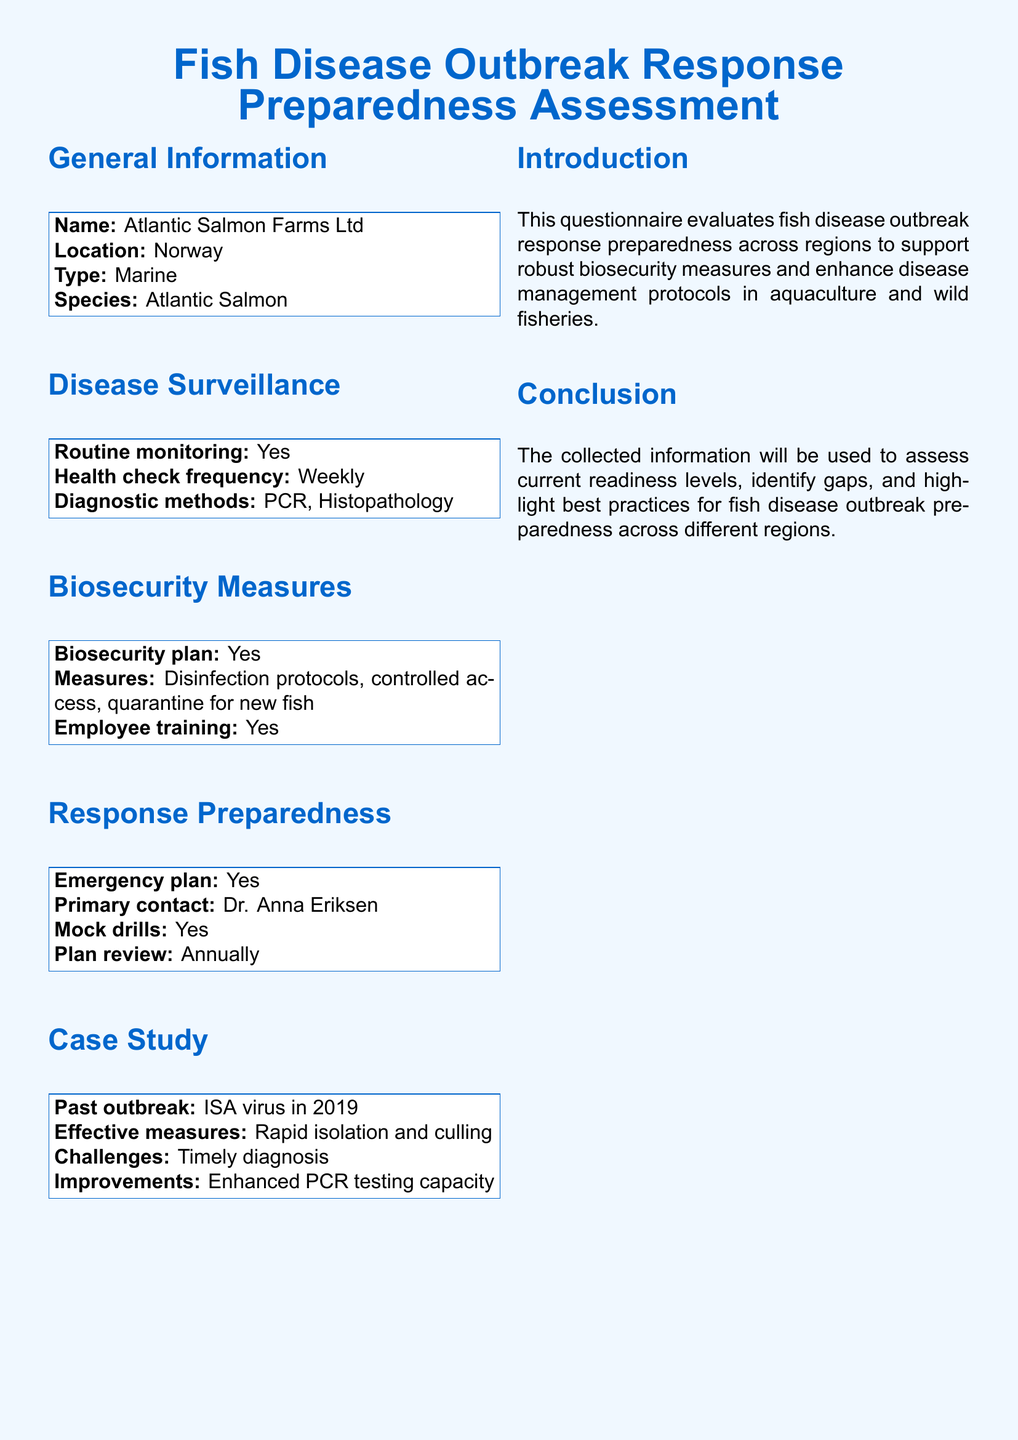What is the name of the organization? The name of the organization is specifically mentioned in the general information section of the document.
Answer: Atlantic Salmon Farms Ltd What is the health check frequency? The health check frequency is listed under the disease surveillance section, which details routine monitoring practices.
Answer: Weekly What diagnostic methods are used? The diagnostic methods are specified in the disease surveillance section, providing insight into the testing practices of the organization.
Answer: PCR, Histopathology Who is the primary contact for the emergency plan? The primary contact name is mentioned in the response preparedness section, where critical personnel are identified.
Answer: Dr. Anna Eriksen What was the past outbreak mentioned? The past outbreak is specifically described in the case study section, outlining historical disease challenges faced by the organization.
Answer: ISA virus in 2019 What improvement was identified for future response? The improvement suggestion is provided in the case study section, focusing on enhancing specific aspects of disease response strategies.
Answer: Enhanced PCR testing capacity How frequently is the emergency plan reviewed? The frequency of the emergency plan review is detailed in the response preparedness section, indicating how often protocols are evaluated for effectiveness.
Answer: Annually What biosecurity measures are in place? The measures implemented for biosecurity are listed in the biosecurity measures section, highlighting protocols and practices.
Answer: Disinfection protocols, controlled access, quarantine for new fish What type of aquaculture is being assessed? The type of aquaculture is noted in the general information section, providing context on the environment being studied.
Answer: Marine 